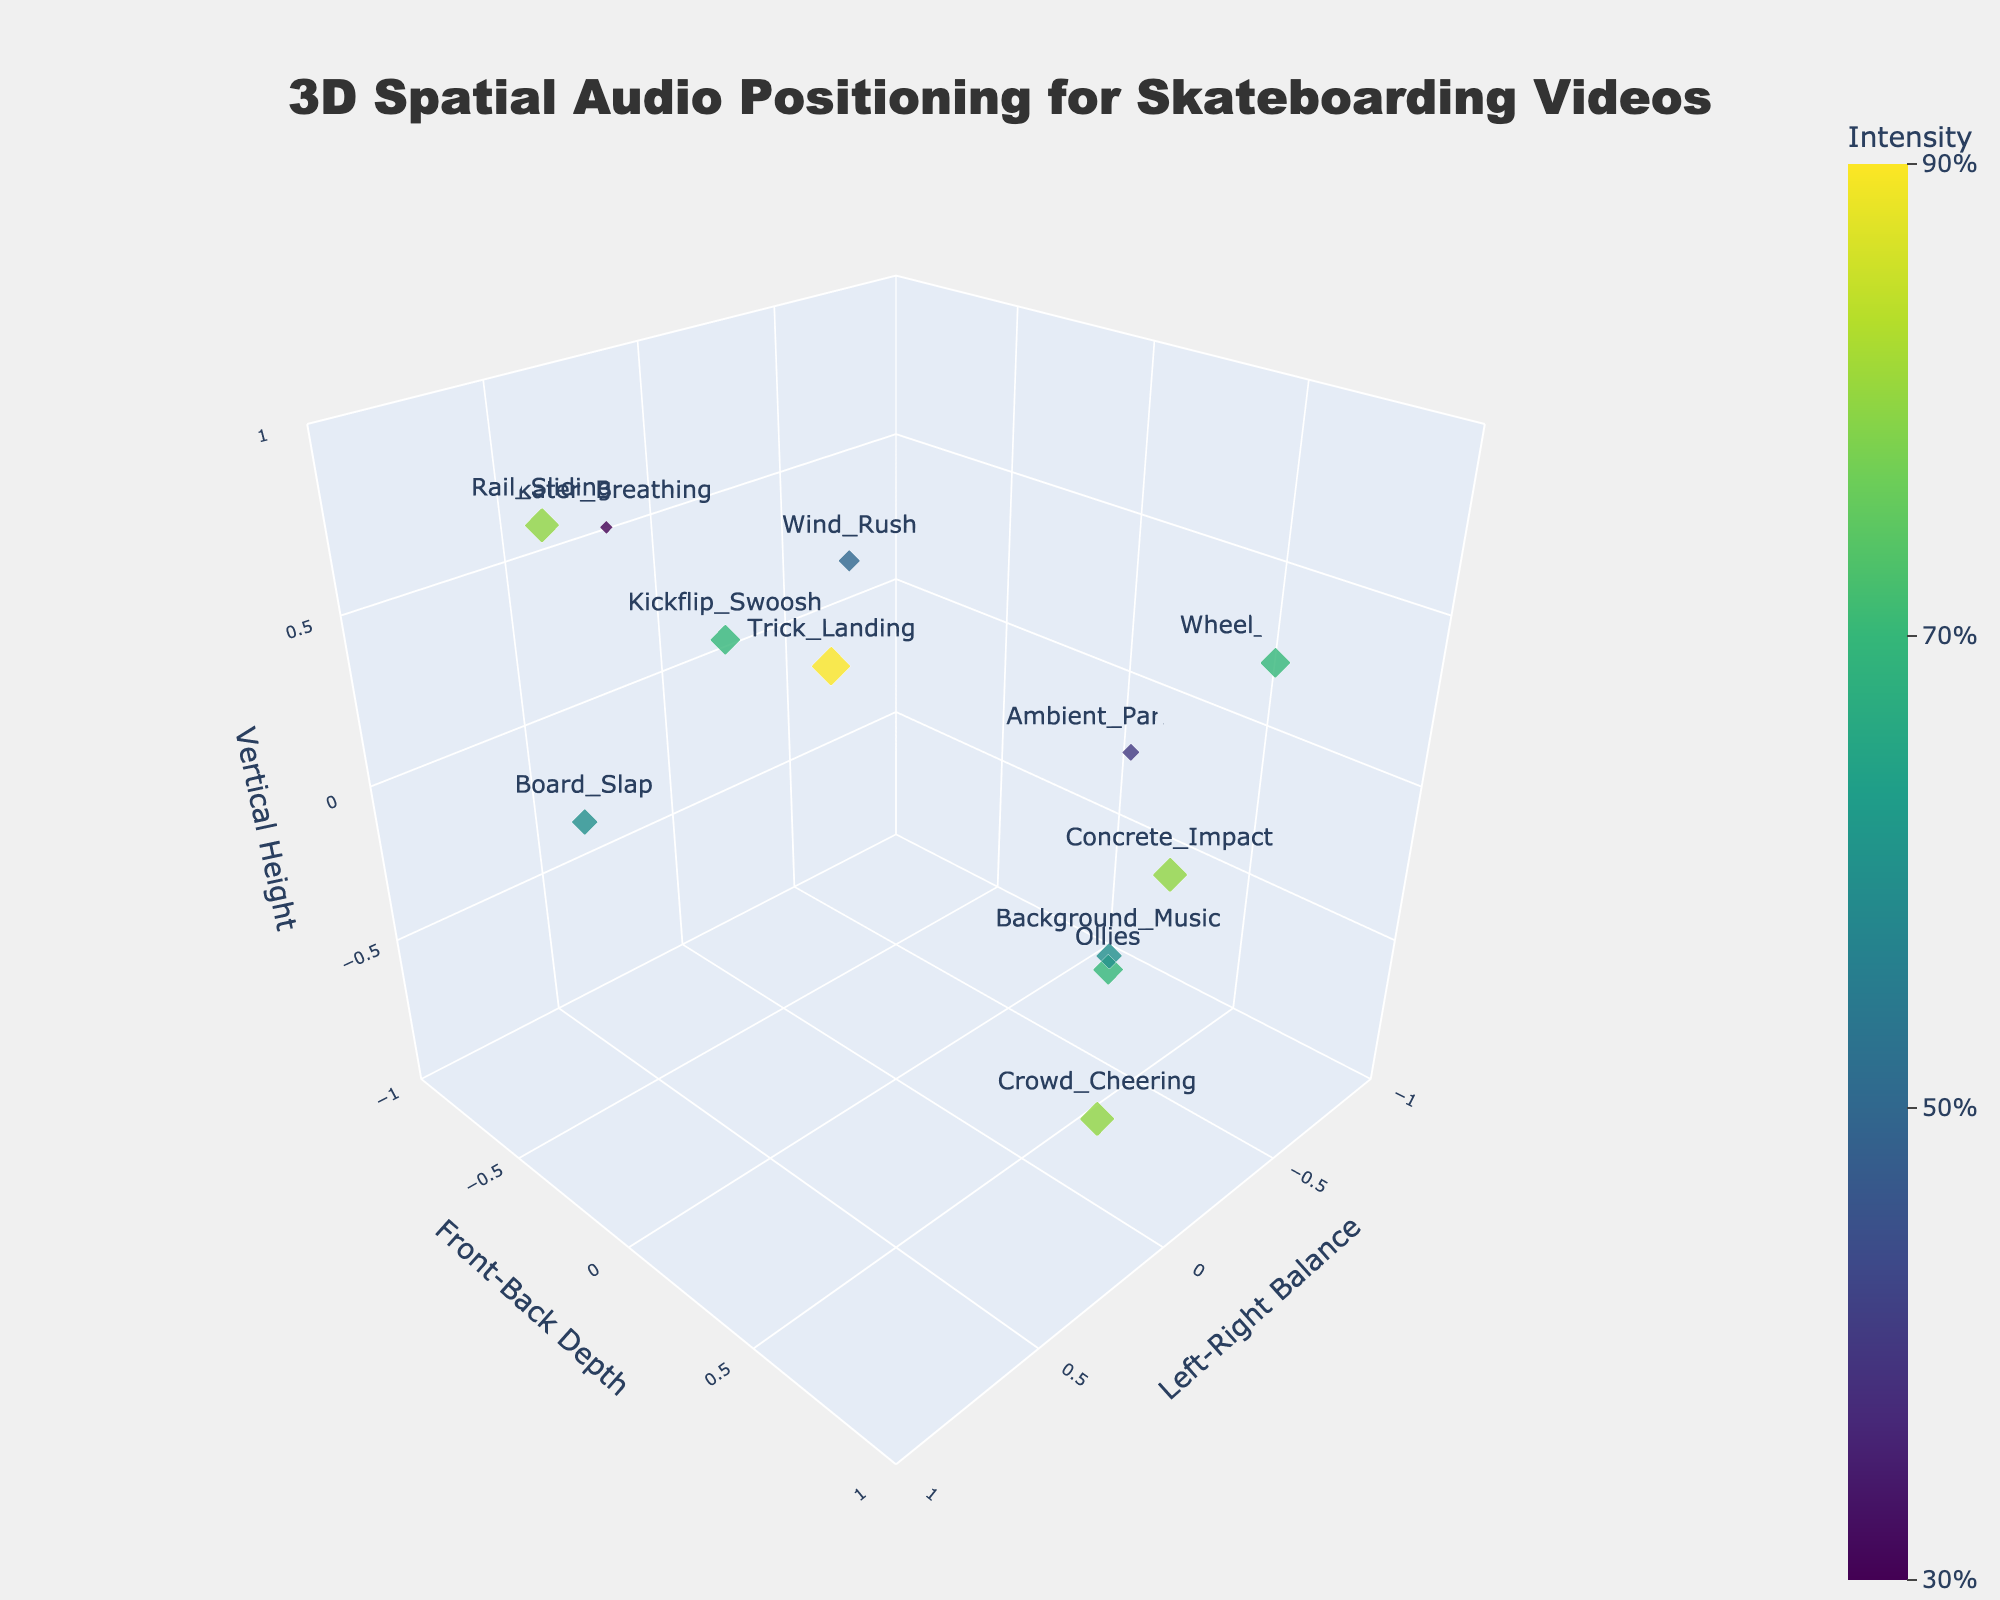How many unique sound elements are mapped on the plot? Count the labeled sound elements displayed in the plot. Each label corresponds to a unique sound element.
Answer: 12 What does the size of the markers represent? Notice that the size of the markers scales with the 'Intensity' values of the sound elements, making higher intensity values larger in size.
Answer: Intensity Which sound element is positioned at the highest vertical height? Look for the marker positioned at the highest z-axis value in the plot, which represents the vertical height. The sound element label next to this marker indicates the answer.
Answer: Rail_Sliding What is the intensity of the Board_Slap sound element? Find the marker labeled 'Board_Slap' and refer to the hover text or color bar to match the intensity value.
Answer: 0.6 Which sound element has the highest intensity? Check the size of the markers, and find the largest one, which corresponds to the highest intensity value.
Answer: Trick_Landing How does the Wind_Rush sound element compare to Ambient_Park_Noise in terms of vertical height? Compare their z-axis values in the plot. Wind_Rush has a z value of 0.3, and Ambient_Park_Noise has a z value of -0.2. Thus, Wind_Rush is higher.
Answer: Wind_Rush is higher What are the coordinates for the Crowd_Cheering sound element? Find the marker labeled 'Crowd_Cheering' and note its x, y, and z values from its position in the plot.
Answer: (0.2, 0.9, -0.5) Which sound element is closest to the center of the plot in terms of 3D distance? Calculate the Euclidean distance from the center for each sound element, \(\sqrt{x^2 + y^2 + z^2}\). The smallest distance indicates the closest sound element to the center.
Answer: Board_Slap Are there any sound elements positioned on the front-left of the plot? Identify sound elements with negative x (left) and positive y (front) values. 'Ollies' and 'Wind_Rush' qualify.
Answer: Yes, Ollies and Wind_Rush What's the average intensity of all sound elements? Add up the intensity values of all 12 sound elements and divide by 12 to find the average. The sum is \(0.7 + 0.6 + 0.8 + 0.5 + 0.9 + 0.4 + 0.3 + 0.7 + 0.8 + 0.6 + 0.7 + 0.8 = 8.1\). So, the average is \(8.1/12 \approx 0.675\).
Answer: 0.675 